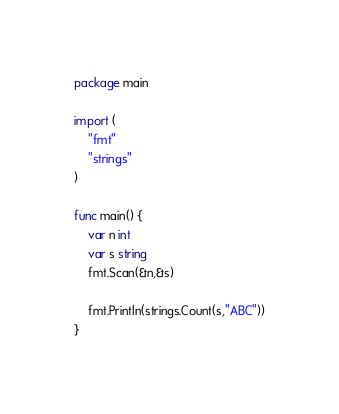Convert code to text. <code><loc_0><loc_0><loc_500><loc_500><_Go_>package main

import (
	"fmt"
	"strings"
)

func main() {
	var n int
	var s string
	fmt.Scan(&n,&s)

	fmt.Println(strings.Count(s,"ABC"))
}</code> 